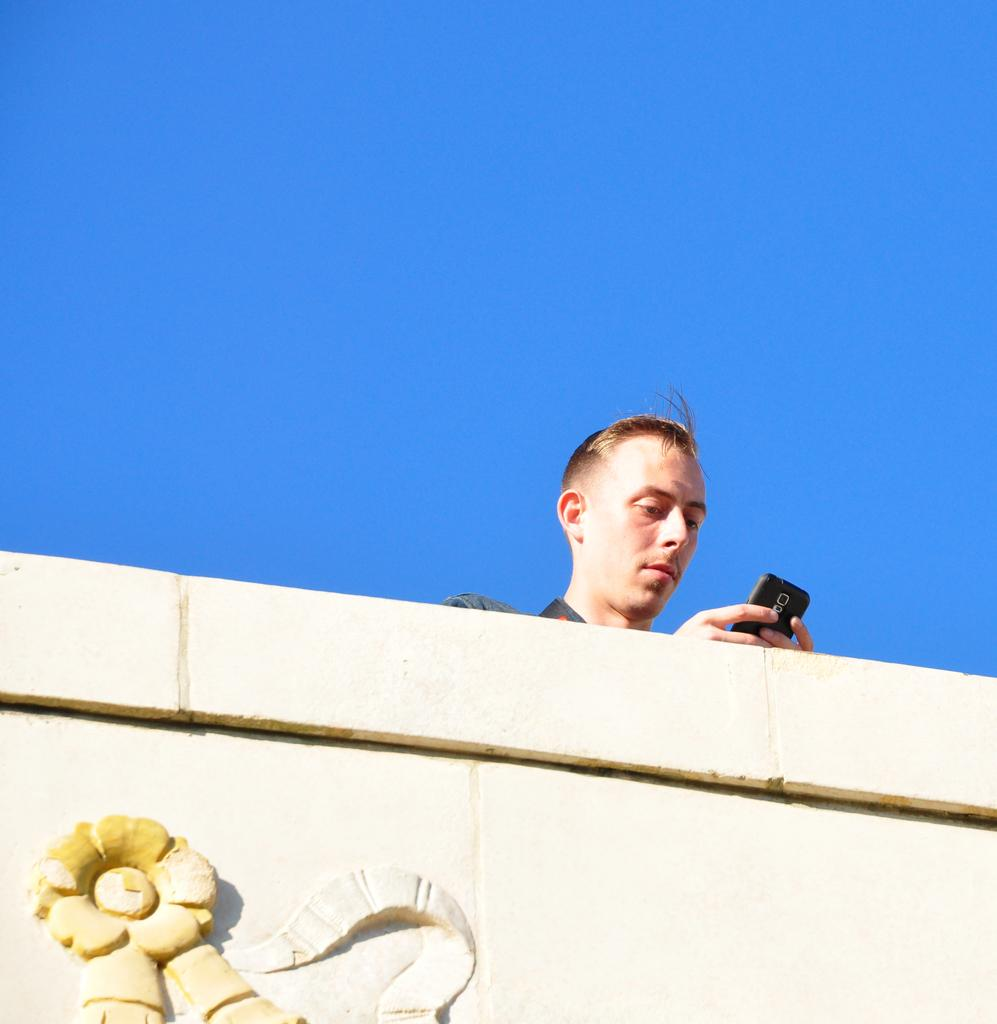Who or what is present in the image? There is a person in the image. What is the person holding in the image? The person is holding a mobile. What can be seen at the bottom of the image? There is a wall with carving at the bottom of the image. What is visible in the background of the image? The sky is visible in the background of the image. What type of trade is being conducted in the image? There is no indication of any trade being conducted in the image; it primarily features a person holding a mobile. How many pickles can be seen in the image? There are no pickles present in the image. 